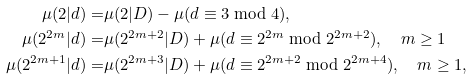Convert formula to latex. <formula><loc_0><loc_0><loc_500><loc_500>\mu ( 2 | d ) = & \mu ( 2 | D ) - \mu ( d \equiv 3 \bmod { 4 } ) , \\ \mu ( 2 ^ { 2 m } | d ) = & \mu ( 2 ^ { 2 m + 2 } | D ) + \mu ( d \equiv 2 ^ { 2 m } \bmod { 2 ^ { 2 m + 2 } } ) , \quad m \geq 1 \\ \mu ( 2 ^ { 2 m + 1 } | d ) = & \mu ( 2 ^ { 2 m + 3 } | D ) + \mu ( d \equiv 2 ^ { 2 m + 2 } \bmod { 2 ^ { 2 m + 4 } } ) , \quad m \geq 1 ,</formula> 